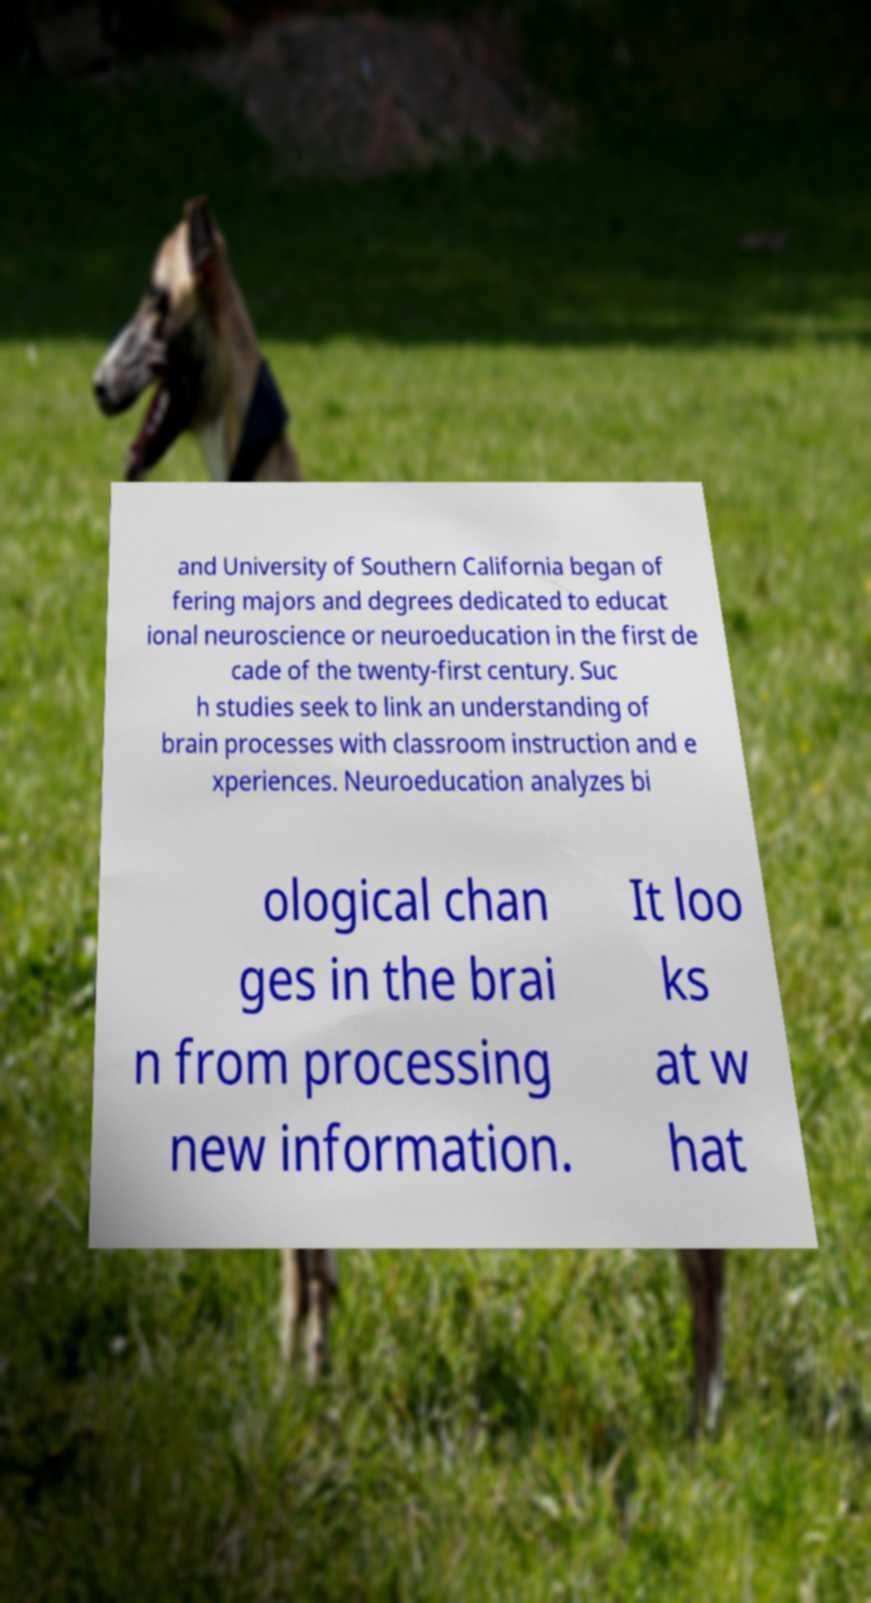What messages or text are displayed in this image? I need them in a readable, typed format. and University of Southern California began of fering majors and degrees dedicated to educat ional neuroscience or neuroeducation in the first de cade of the twenty-first century. Suc h studies seek to link an understanding of brain processes with classroom instruction and e xperiences. Neuroeducation analyzes bi ological chan ges in the brai n from processing new information. It loo ks at w hat 